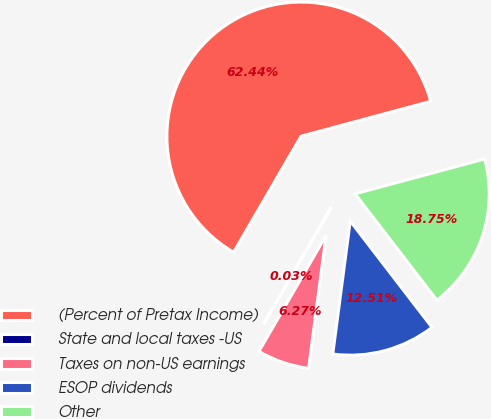Convert chart to OTSL. <chart><loc_0><loc_0><loc_500><loc_500><pie_chart><fcel>(Percent of Pretax Income)<fcel>State and local taxes -US<fcel>Taxes on non-US earnings<fcel>ESOP dividends<fcel>Other<nl><fcel>62.43%<fcel>0.03%<fcel>6.27%<fcel>12.51%<fcel>18.75%<nl></chart> 